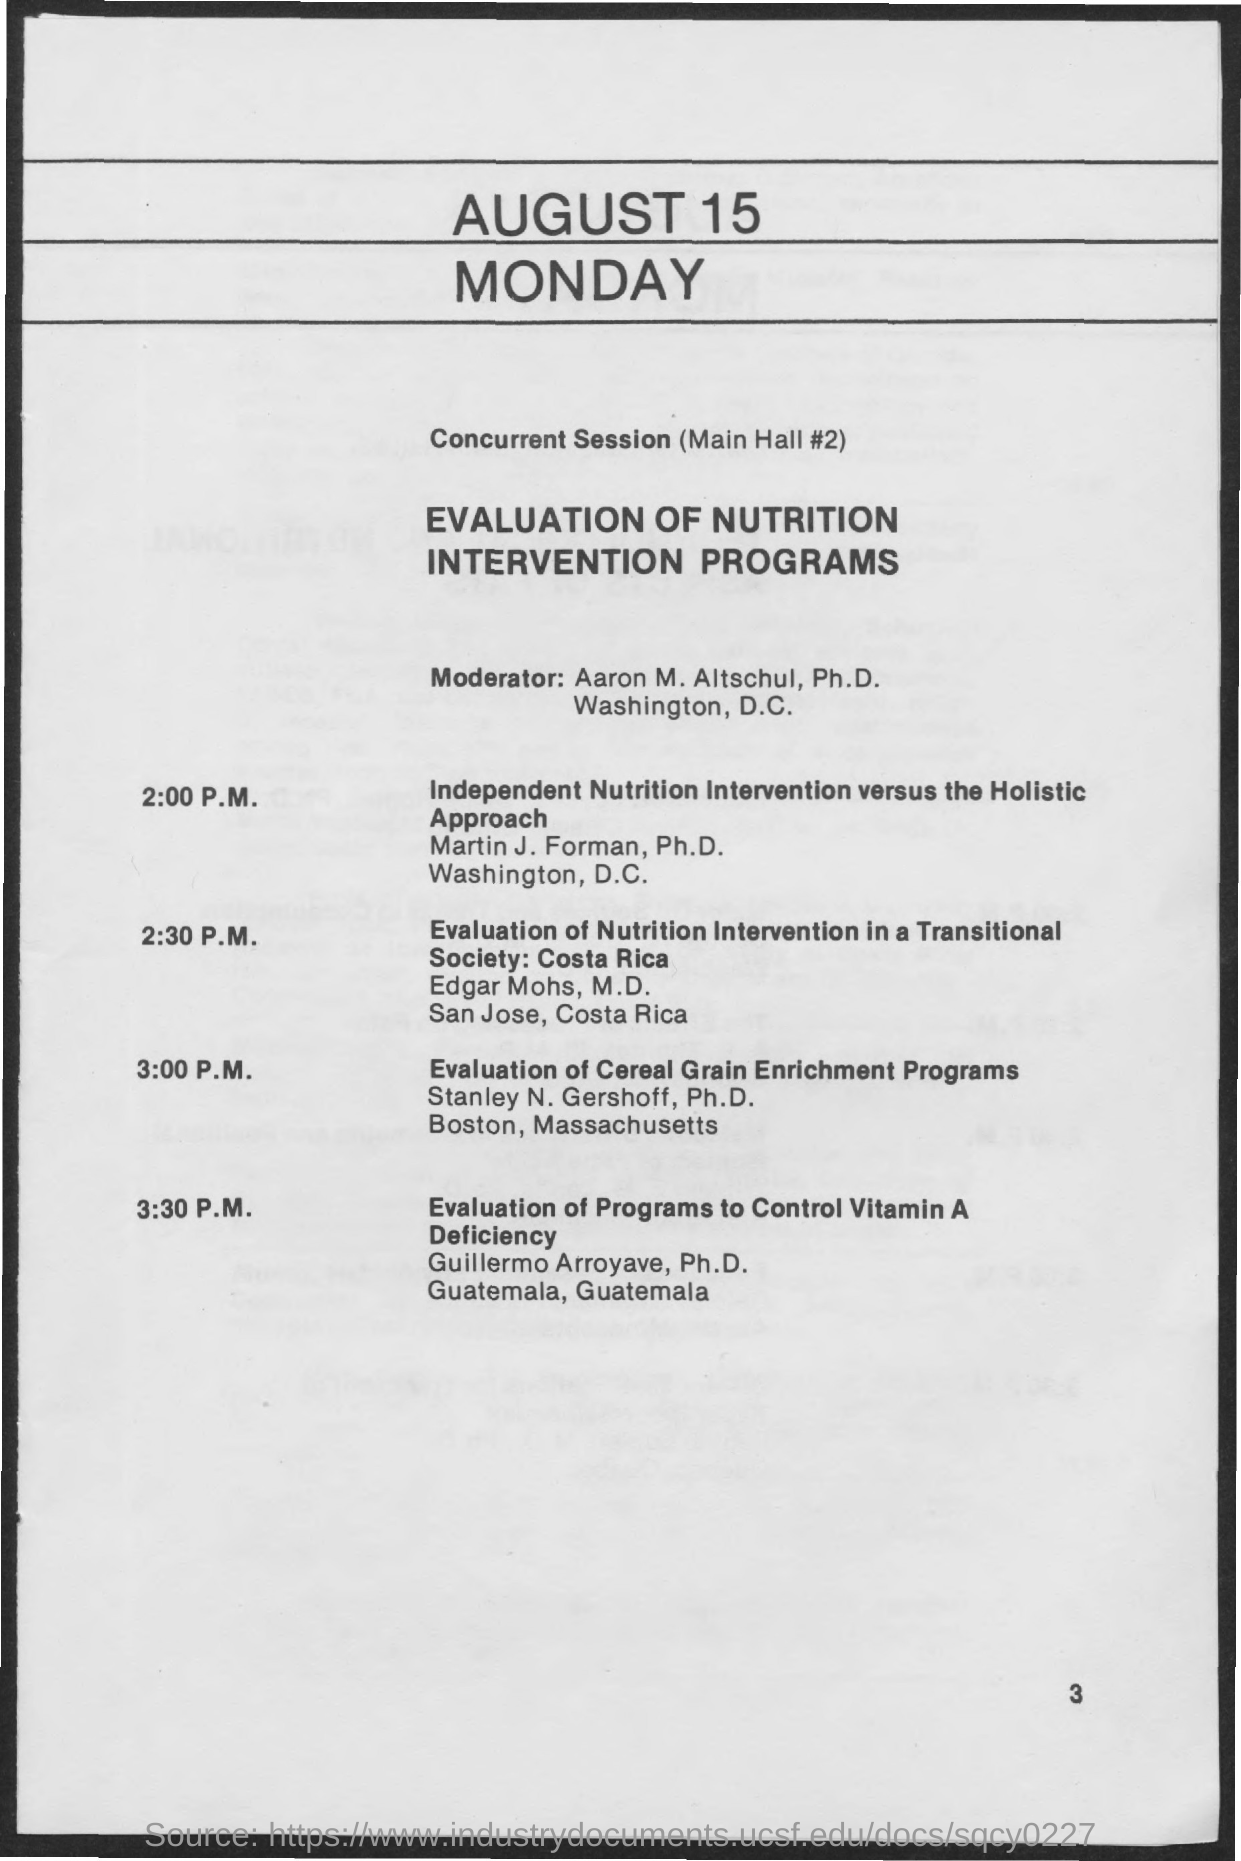Point out several critical features in this image. At 2:30 P.M., the handling of the session will be handled by Edgar Mohs, M.D. At 3:30 P.M., there will be an evaluation of programs designed to control vitamin A deficiency. The moderator of this program is Aaron M. Altschul, Ph.D. The session at 2:30 P.M. will be an evaluation of the nutrition intervention in a transitional society, specifically in Costa Rica. The individual named Martin J. Forman, Ph.D. handles the 2:00 P.M. session. 